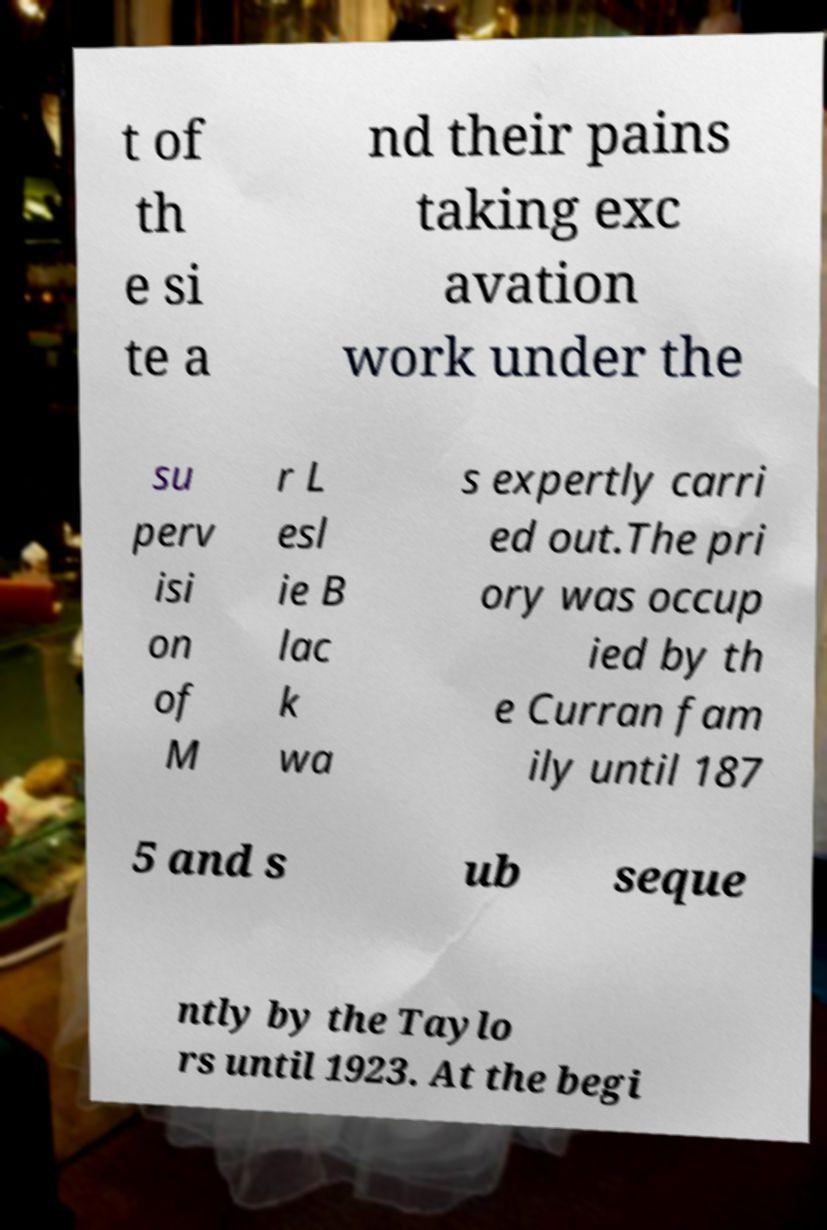Can you accurately transcribe the text from the provided image for me? t of th e si te a nd their pains taking exc avation work under the su perv isi on of M r L esl ie B lac k wa s expertly carri ed out.The pri ory was occup ied by th e Curran fam ily until 187 5 and s ub seque ntly by the Taylo rs until 1923. At the begi 